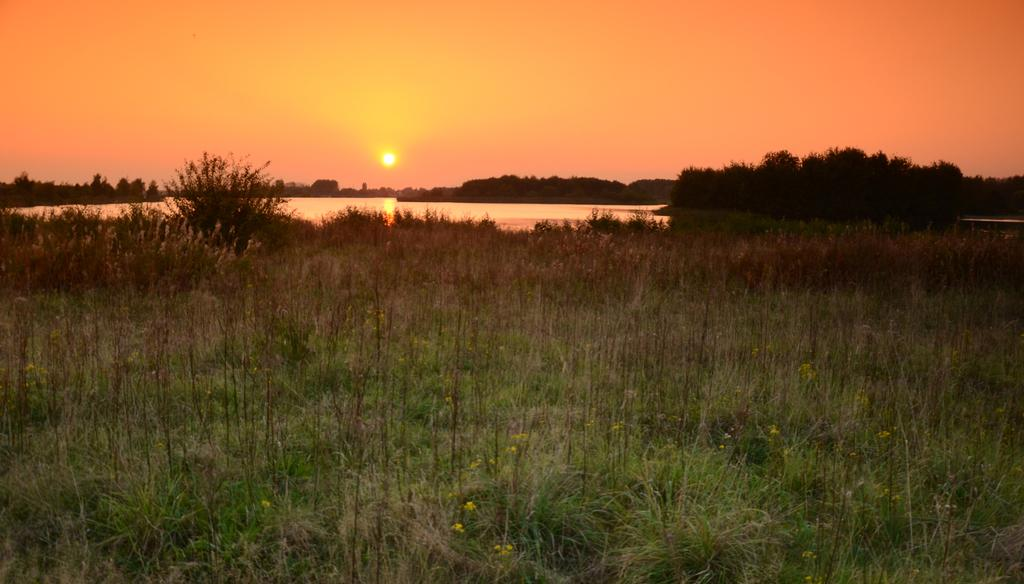What is the main object in the image? There is a pot in the image. What can be seen in the sky in the image? The sun is visible in the image. What type of vegetation is present in the image? There are plants and trees in the image. What type of owl can be seen perched on the pot in the image? There is no owl present in the image; it only features a pot, the sun, plants, and trees. What is the zinc content of the pot in the image? The composition of the pot, including its zinc content, cannot be determined from the image. 